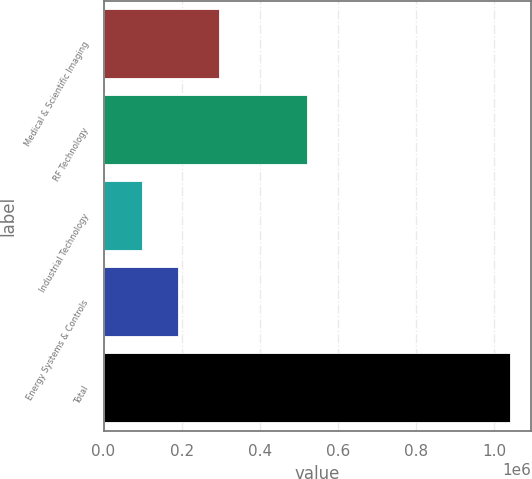Convert chart to OTSL. <chart><loc_0><loc_0><loc_500><loc_500><bar_chart><fcel>Medical & Scientific Imaging<fcel>RF Technology<fcel>Industrial Technology<fcel>Energy Systems & Controls<fcel>Total<nl><fcel>296098<fcel>520727<fcel>97507<fcel>191873<fcel>1.04117e+06<nl></chart> 